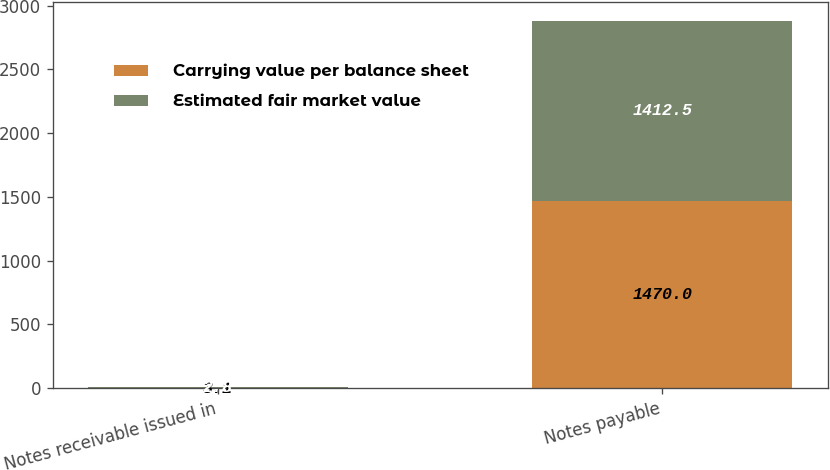Convert chart to OTSL. <chart><loc_0><loc_0><loc_500><loc_500><stacked_bar_chart><ecel><fcel>Notes receivable issued in<fcel>Notes payable<nl><fcel>Carrying value per balance sheet<fcel>3.1<fcel>1470<nl><fcel>Estimated fair market value<fcel>2.8<fcel>1412.5<nl></chart> 